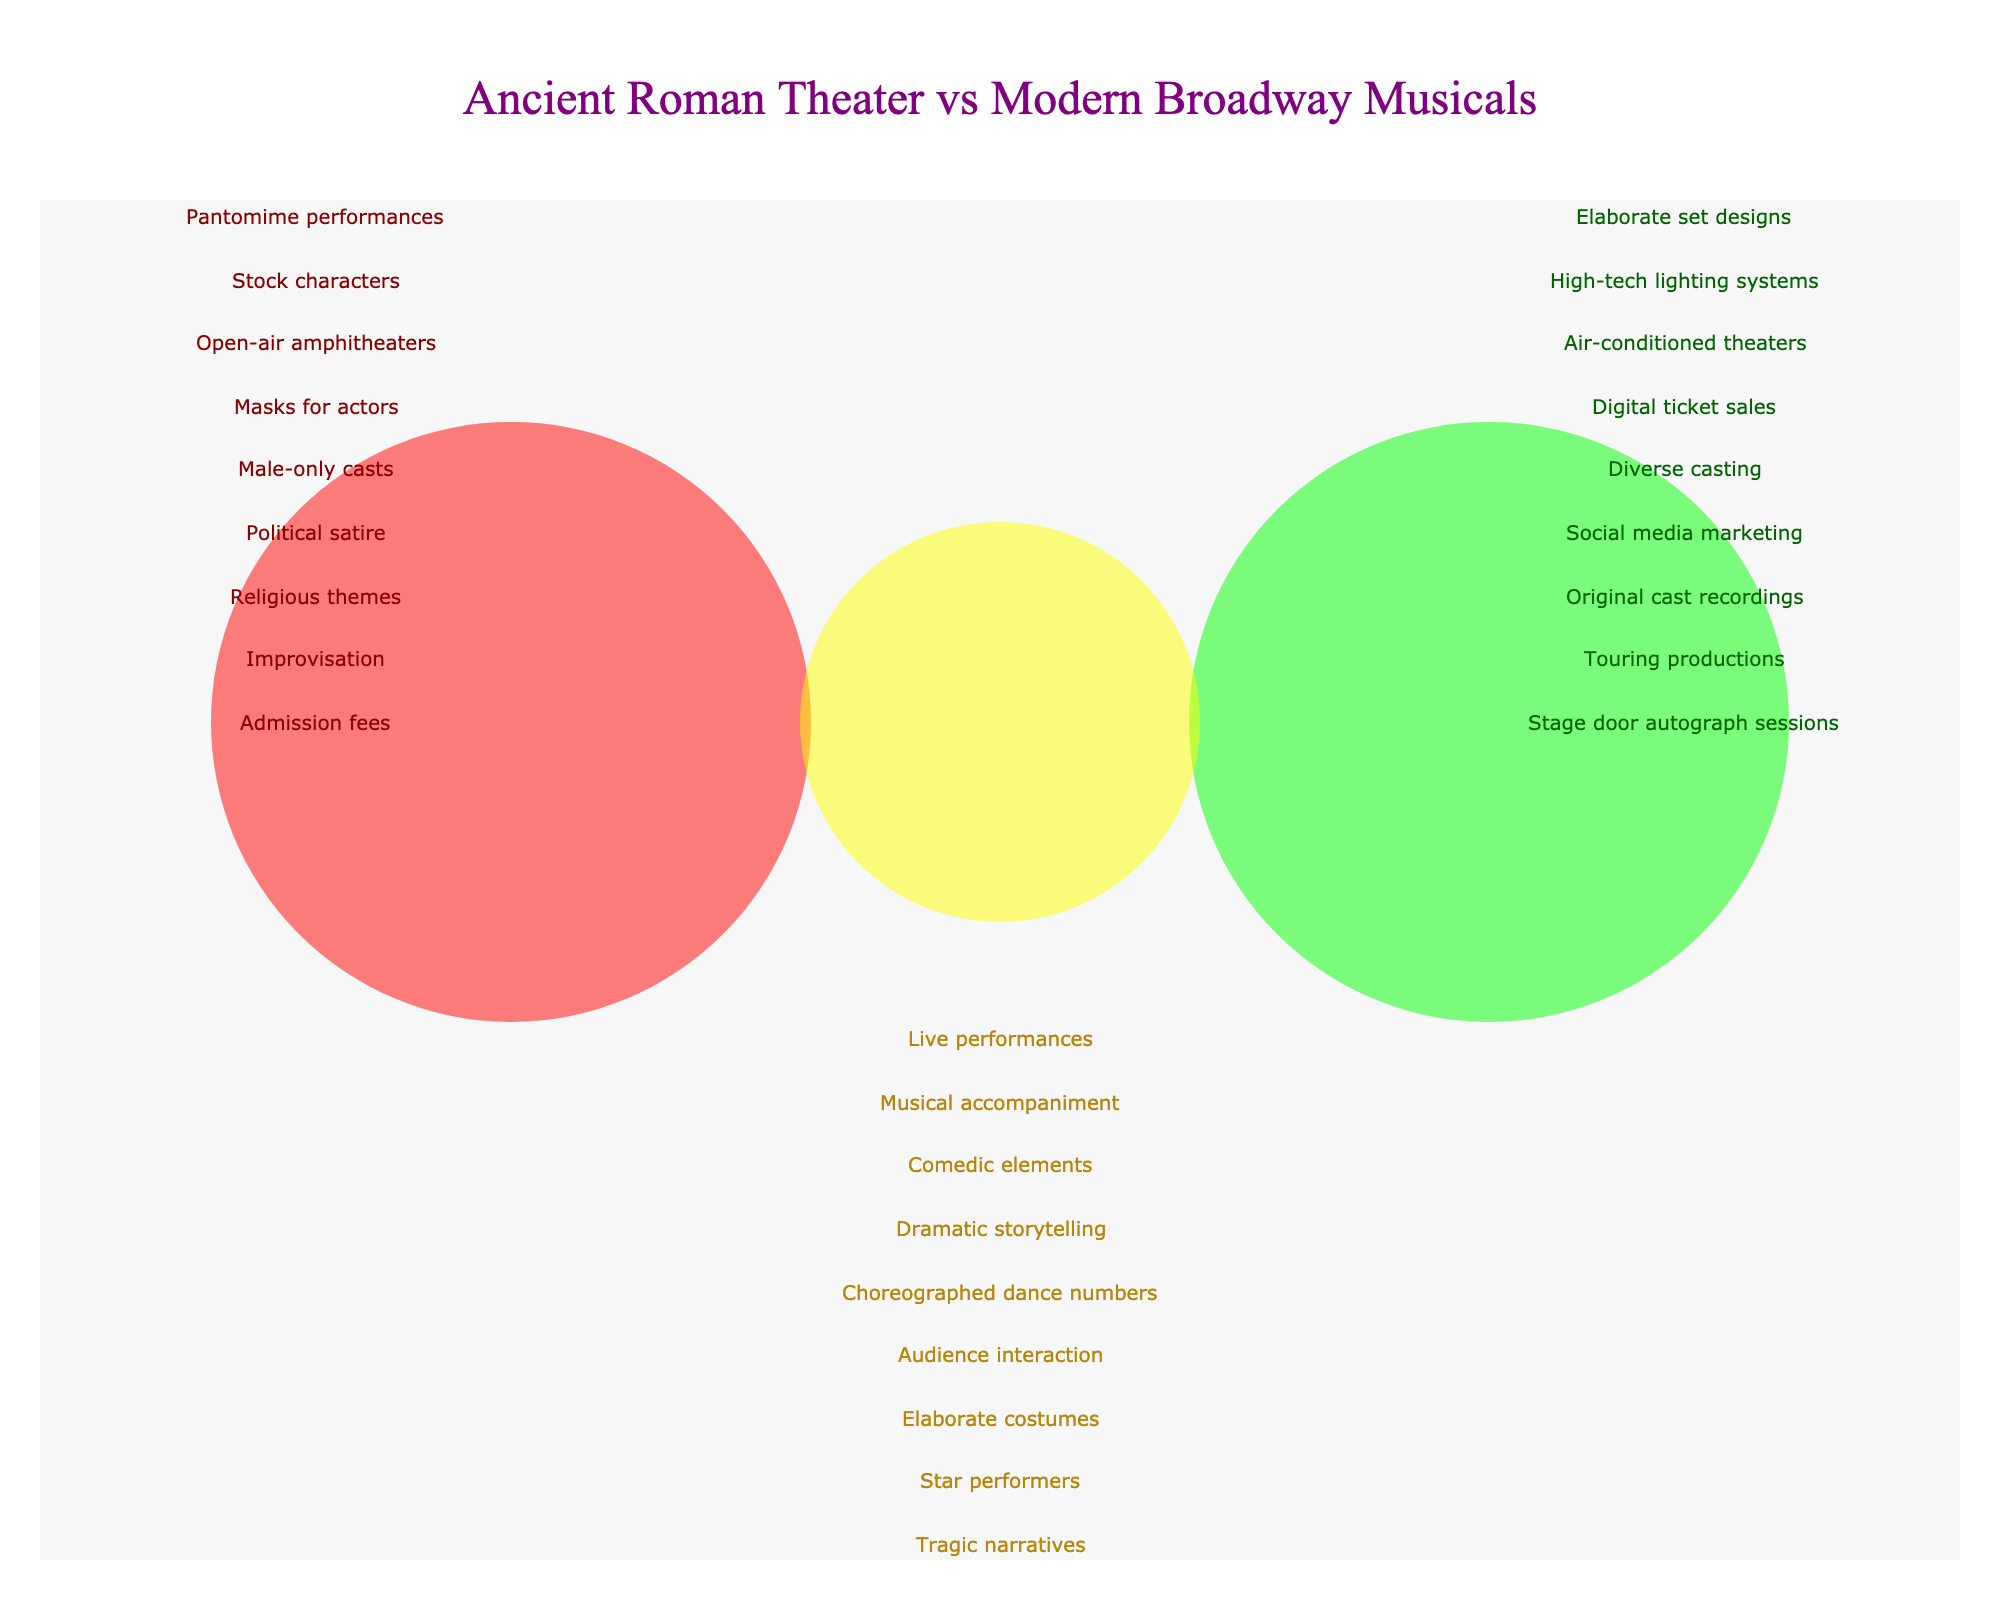What is the title of the figure? The title is usually positioned at the top of the figure. In this case, the text at the top reads "Ancient Roman Theater vs Modern Broadway Musicals."
Answer: Ancient Roman Theater vs Modern Broadway Musicals What are the two main groups being compared in the Venn Diagram? The Venn Diagram visually represents two main groups through circles. The text within or near these circles labels them as "Ancient Roman Theater" and "Modern Broadway Musicals."
Answer: Ancient Roman Theater and Modern Broadway Musicals How many shared elements are there between Ancient Roman Theater and Modern Broadway Musicals? By counting the distinct annotations within the shared section (the overlap between the two circles), we find the shared elements.
Answer: 10 Which category has "Masks for actors"? "Masks for actors" is annotated near the "Ancient Roman Theater" circle.
Answer: Ancient Roman Theater How many unique elements are listed for Modern Broadway Musicals? By counting the annotations near the "Modern Broadway Musicals" circle, we determine the number of unique elements.
Answer: 10 What is the element that involves direct interaction with the audience? The annotations in the shared section include "Audience interaction," indicating that this element is shared between both groups.
Answer: Audience interaction Which group has elements related to technology, and what are they? The annotations near "Modern Broadway Musicals" include elements such as "High-tech lighting systems," "Digital ticket sales," and "Social media marketing," indicating advanced use of technology.
Answer: Modern Broadway Musicals (High-tech lighting systems, Digital ticket sales, Social media marketing) What are the elements related to performances in Ancient Roman Theater and Modern Broadway Musicals? The elements in "Ancient Roman Theater" like "Pantomime performances," "Stock characters," and "Improvisation" are related to performance styles, as well as "Choreographed dance numbers" and "Star performers" in "Modern Broadway Musicals." These provide insight into performance types in both.
Answer: Pantomime performances, Stock characters, Improvisation (Ancient Roman Theater); Choreographed dance numbers, Star performers (Modern Broadway Musicals) Which group has more elements related to the physical environment of their performances? Checking the annotations, "Open-air amphitheaters" is the only element from "Ancient Roman Theater," whereas "Elaborate set designs," "High-tech lighting systems," and "Air-conditioned theaters" are elements from "Modern Broadway Musicals."
Answer: Modern Broadway Musicals 